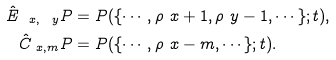<formula> <loc_0><loc_0><loc_500><loc_500>\hat { E } _ { \ x , \ y } P & = P ( \{ \cdots , \rho _ { \ } x + 1 , \rho _ { \ } y - 1 , \cdots \} ; t ) , \\ \hat { C } _ { \ x , m } P & = P ( \{ \cdots , \rho _ { \ } x - m , \cdots \} ; t ) .</formula> 